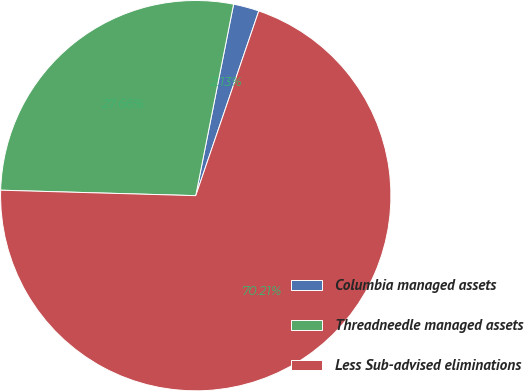Convert chart to OTSL. <chart><loc_0><loc_0><loc_500><loc_500><pie_chart><fcel>Columbia managed assets<fcel>Threadneedle managed assets<fcel>Less Sub-advised eliminations<nl><fcel>2.13%<fcel>27.66%<fcel>70.21%<nl></chart> 